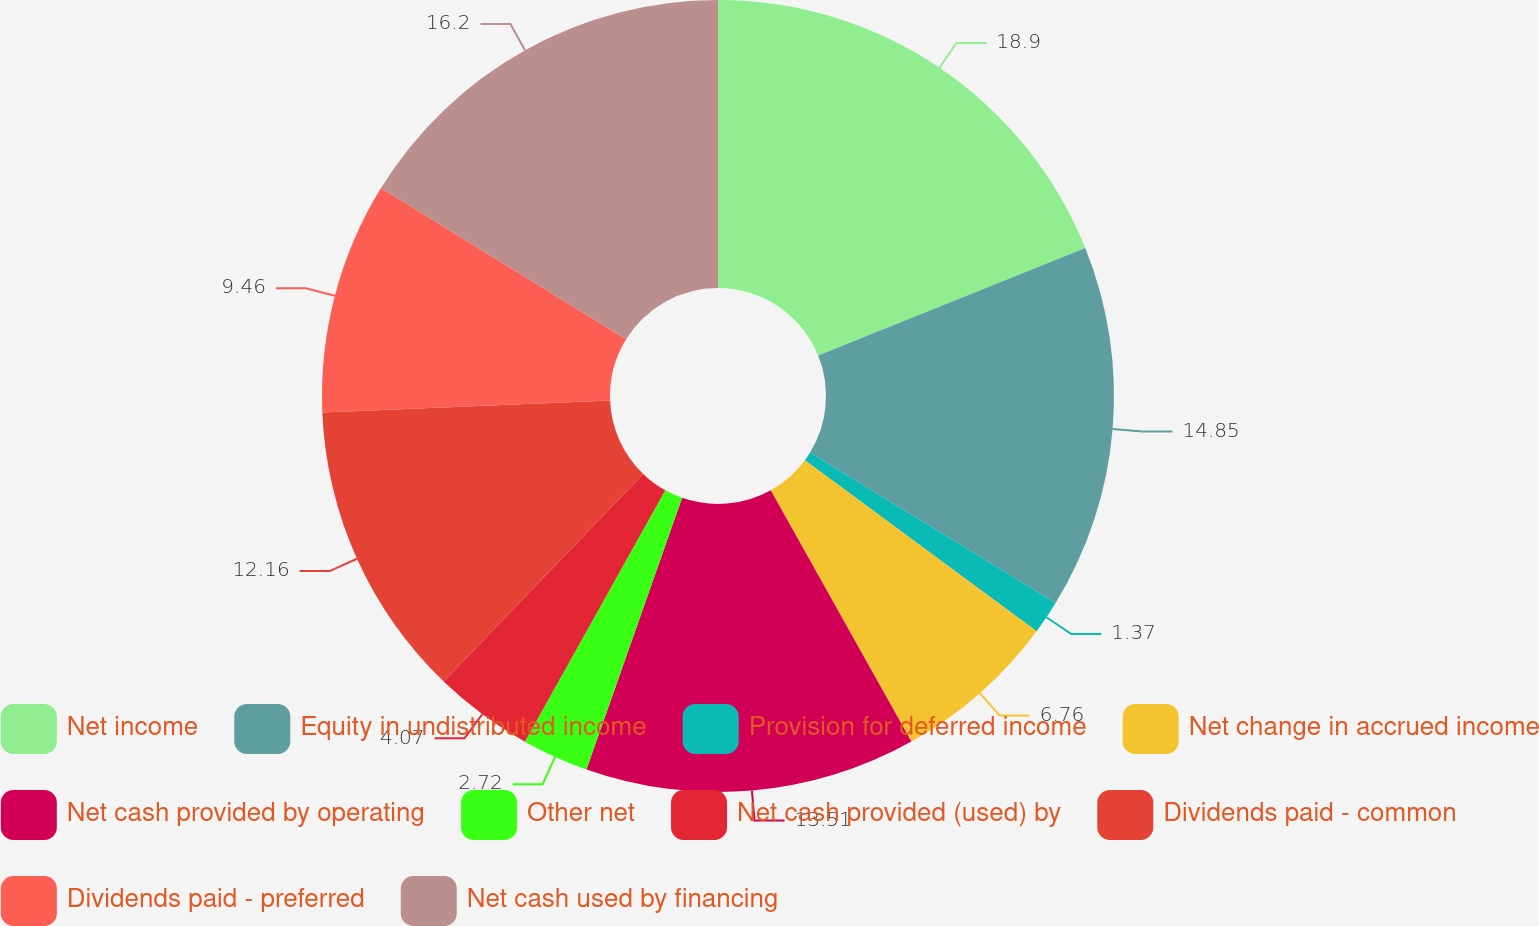Convert chart to OTSL. <chart><loc_0><loc_0><loc_500><loc_500><pie_chart><fcel>Net income<fcel>Equity in undistributed income<fcel>Provision for deferred income<fcel>Net change in accrued income<fcel>Net cash provided by operating<fcel>Other net<fcel>Net cash provided (used) by<fcel>Dividends paid - common<fcel>Dividends paid - preferred<fcel>Net cash used by financing<nl><fcel>18.9%<fcel>14.85%<fcel>1.37%<fcel>6.76%<fcel>13.51%<fcel>2.72%<fcel>4.07%<fcel>12.16%<fcel>9.46%<fcel>16.2%<nl></chart> 